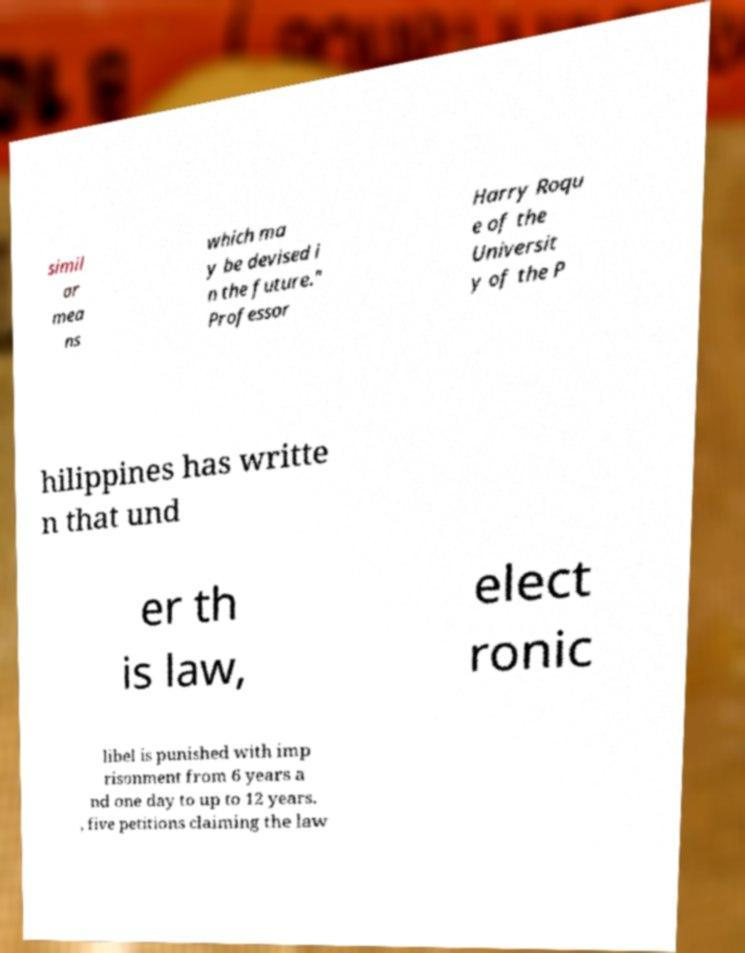For documentation purposes, I need the text within this image transcribed. Could you provide that? simil ar mea ns which ma y be devised i n the future." Professor Harry Roqu e of the Universit y of the P hilippines has writte n that und er th is law, elect ronic libel is punished with imp risonment from 6 years a nd one day to up to 12 years. , five petitions claiming the law 